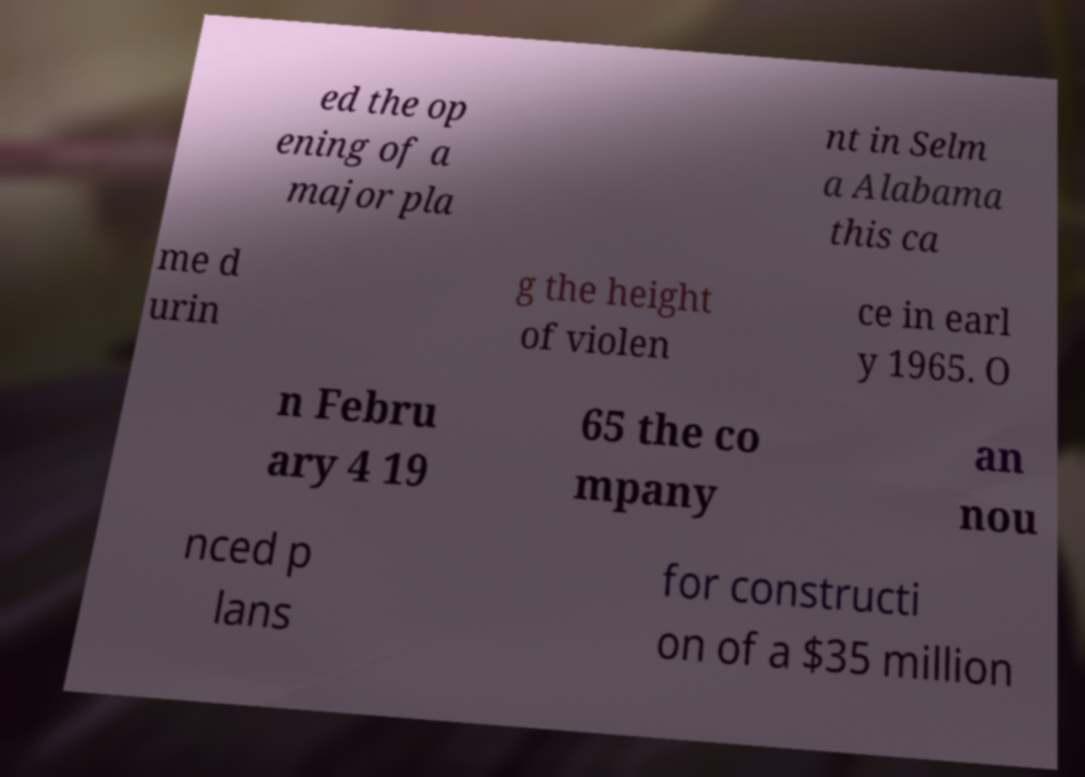Could you extract and type out the text from this image? ed the op ening of a major pla nt in Selm a Alabama this ca me d urin g the height of violen ce in earl y 1965. O n Febru ary 4 19 65 the co mpany an nou nced p lans for constructi on of a $35 million 